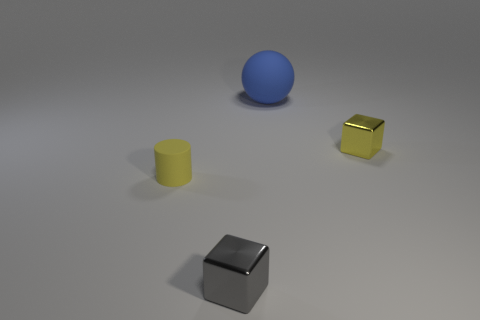Do the small yellow object that is on the left side of the ball and the small yellow cube have the same material?
Offer a very short reply. No. The big object is what shape?
Give a very brief answer. Sphere. How many yellow things are either spheres or small metallic cylinders?
Ensure brevity in your answer.  0. What number of other objects are there of the same material as the large blue thing?
Provide a short and direct response. 1. There is a yellow object in front of the small yellow metal thing; is its shape the same as the gray metal thing?
Your response must be concise. No. Is there a yellow object?
Give a very brief answer. Yes. Is there any other thing that has the same shape as the big object?
Offer a very short reply. No. Is the number of rubber objects on the right side of the tiny rubber thing greater than the number of gray objects?
Offer a very short reply. No. Are there any tiny yellow things to the right of the gray cube?
Your answer should be compact. Yes. Is the size of the blue thing the same as the yellow rubber object?
Your answer should be compact. No. 